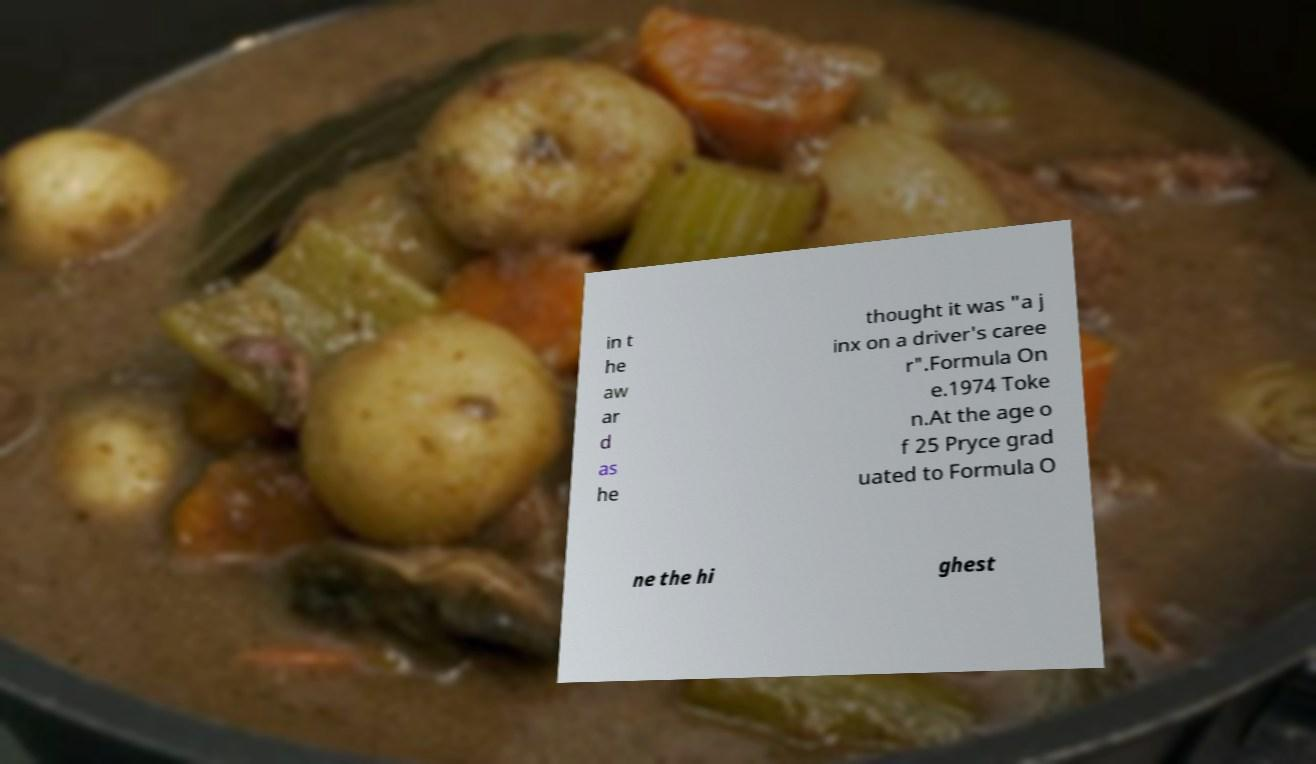Could you assist in decoding the text presented in this image and type it out clearly? in t he aw ar d as he thought it was "a j inx on a driver's caree r".Formula On e.1974 Toke n.At the age o f 25 Pryce grad uated to Formula O ne the hi ghest 